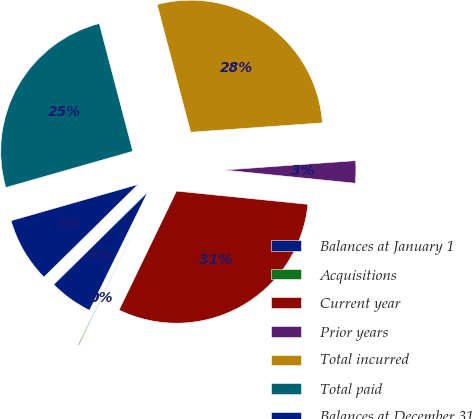Convert chart. <chart><loc_0><loc_0><loc_500><loc_500><pie_chart><fcel>Balances at January 1<fcel>Acquisitions<fcel>Current year<fcel>Prior years<fcel>Total incurred<fcel>Total paid<fcel>Balances at December 31<nl><fcel>5.34%<fcel>0.12%<fcel>30.56%<fcel>2.73%<fcel>27.95%<fcel>25.34%<fcel>7.95%<nl></chart> 